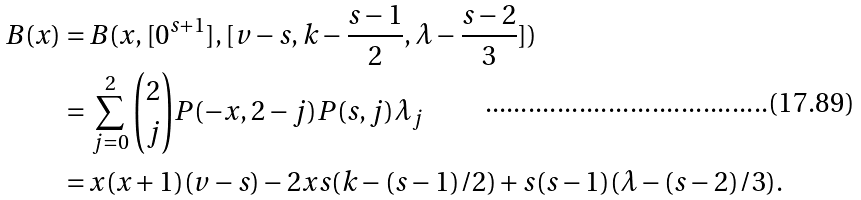<formula> <loc_0><loc_0><loc_500><loc_500>B ( x ) = & \, B ( x , [ 0 ^ { s + 1 } ] , [ v - s , k - \frac { s - 1 } { 2 } , \lambda - \frac { s - 2 } { 3 } ] ) \\ = & \, \sum _ { j = 0 } ^ { 2 } { 2 \choose j } P ( - x , 2 - j ) P ( s , j ) \lambda _ { j } \\ = & \, x ( x + 1 ) ( v - s ) - 2 x s ( k - ( s - 1 ) / 2 ) + s ( s - 1 ) ( \lambda - ( s - 2 ) / 3 ) .</formula> 